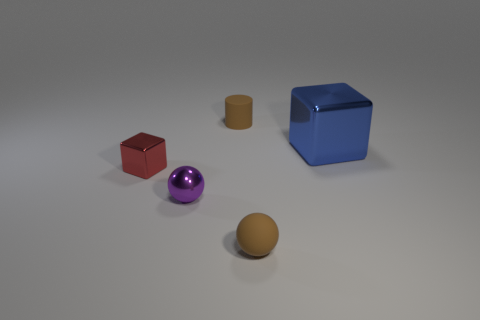Is the size of the metallic ball the same as the cylinder?
Ensure brevity in your answer.  Yes. How many objects are either objects to the left of the small purple shiny thing or tiny red metallic blocks?
Your answer should be compact. 1. Do the red metal object and the big blue metallic thing have the same shape?
Your answer should be very brief. Yes. What number of other things are there of the same size as the matte cylinder?
Offer a terse response. 3. What color is the rubber ball?
Your answer should be compact. Brown. How many small objects are either blue shiny things or balls?
Provide a succinct answer. 2. There is a cube right of the tiny brown sphere; is its size the same as the block left of the small rubber sphere?
Offer a terse response. No. What is the size of the brown thing that is the same shape as the small purple metal object?
Provide a short and direct response. Small. Is the number of small red objects left of the purple sphere greater than the number of small cubes behind the large blue thing?
Provide a succinct answer. Yes. There is a thing that is both in front of the cylinder and behind the red shiny thing; what material is it?
Your answer should be very brief. Metal. 